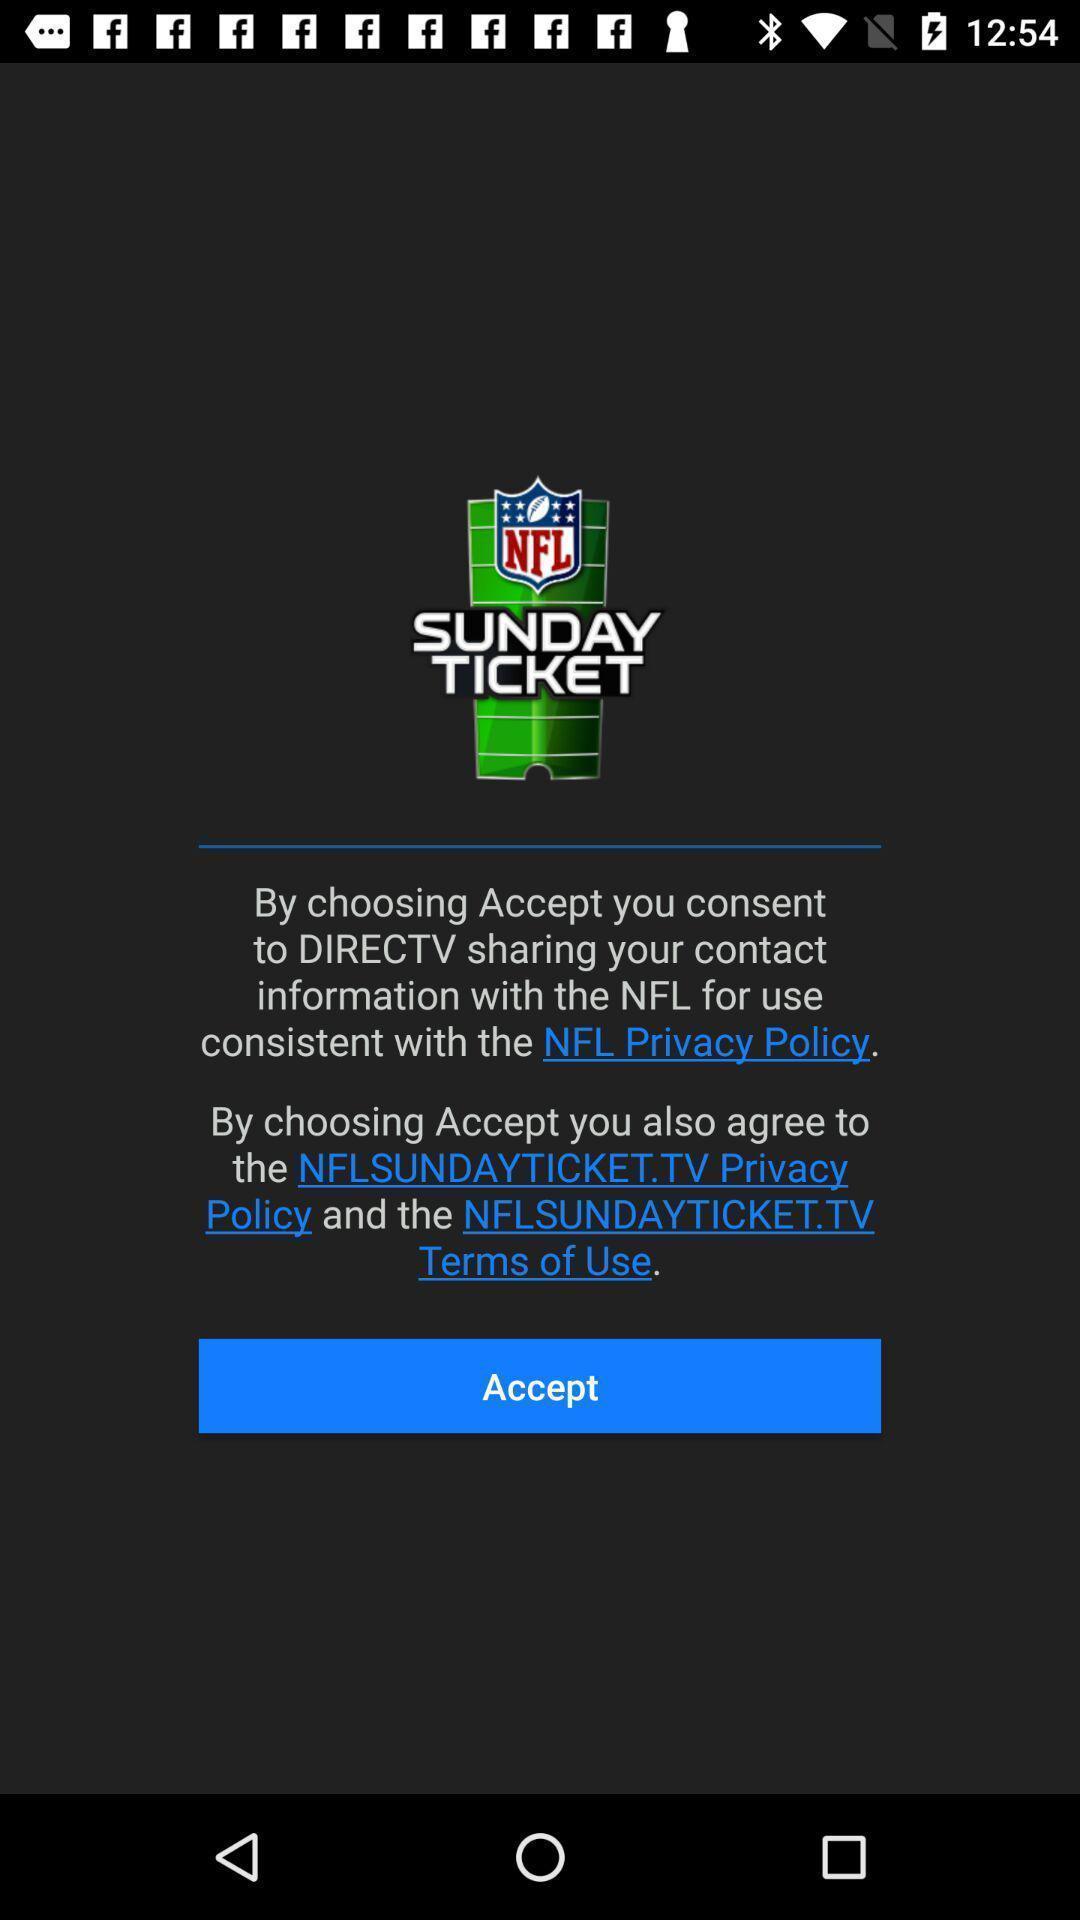Explain the elements present in this screenshot. Pop-up asking to accept the privacy policy. 